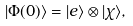<formula> <loc_0><loc_0><loc_500><loc_500>| \Phi ( 0 ) \rangle = | e \rangle \otimes | \chi \rangle ,</formula> 